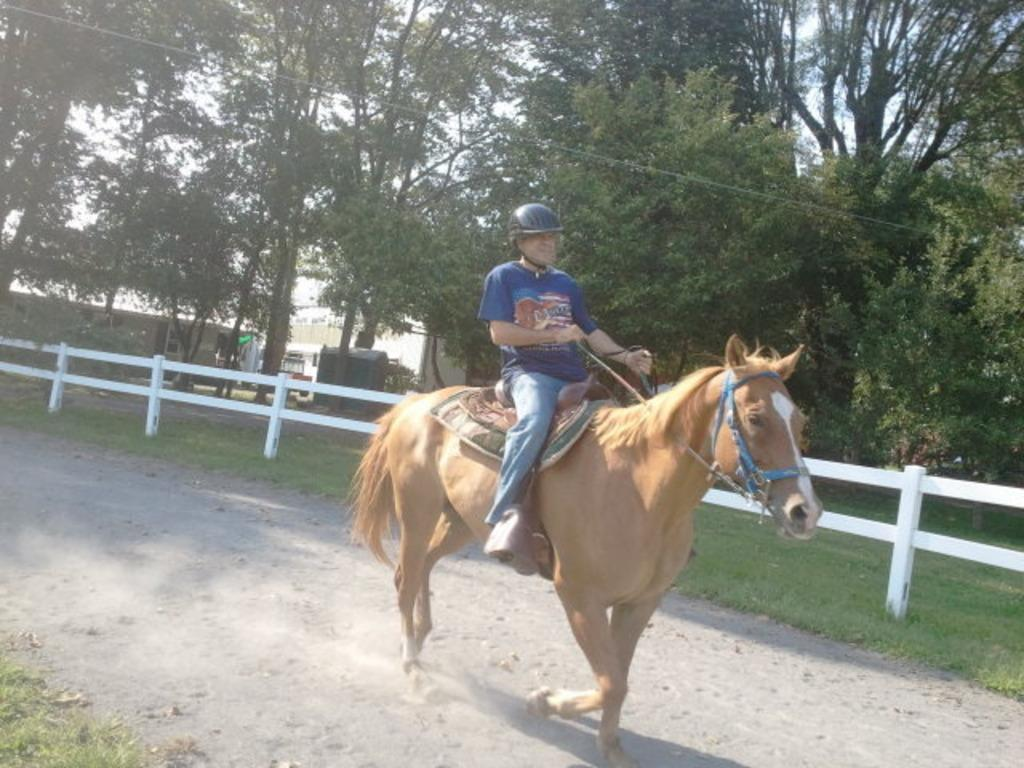What is the man in the image wearing? The man is wearing a blue t-shirt and jeans. What is the man doing in the image? The man is sitting on a horse. What is the horse doing in the image? The horse is walking on a path. What can be seen in the background of the image? There is a fence on grassland and trees visible in the background of the image. What type of feast is being prepared in the image? There is no indication of a feast being prepared in the image; it features a man sitting on a horse walking on a path. 